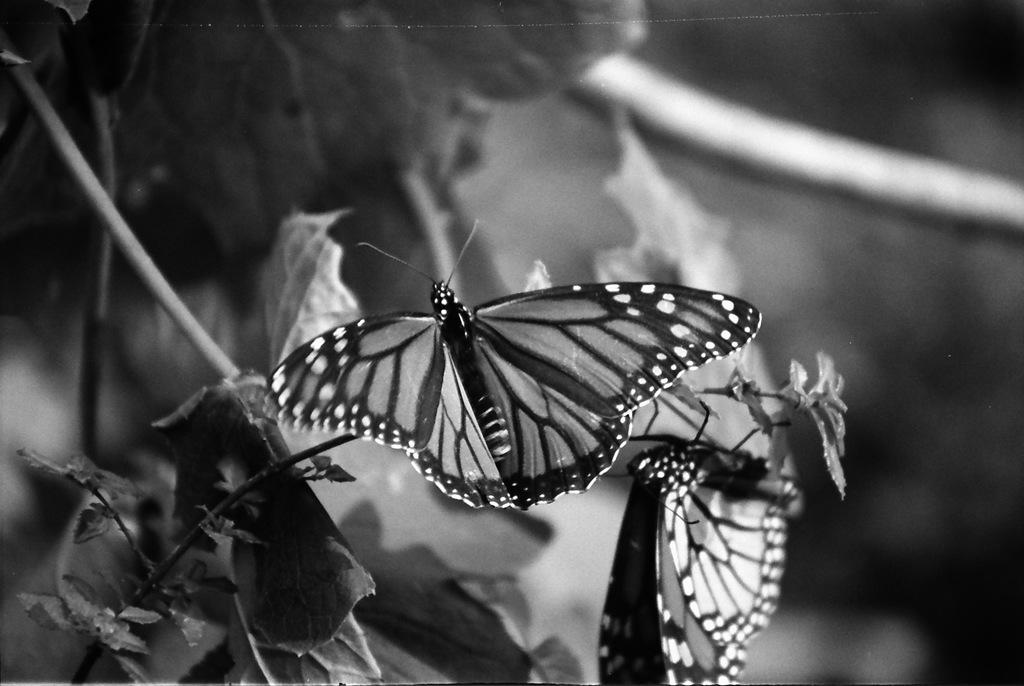What is the main subject of the black and white picture in the image? The main subject of the black and white picture in the image is butterflies. Where are the butterflies located in the picture? The butterflies are on the stems of a plant in the picture. What can be seen in the background of the image? There are plants visible in the background of the image. What type of pen is the butterfly holding in the image? There is no pen present in the image; the butterflies are on the stems of a plant. 